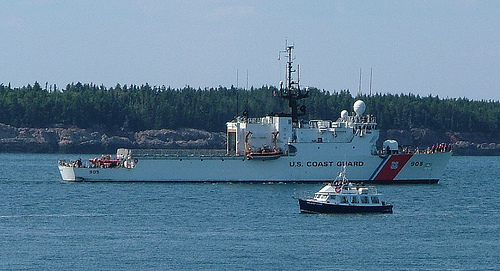<image>
Is the water on the boat? No. The water is not positioned on the boat. They may be near each other, but the water is not supported by or resting on top of the boat. 